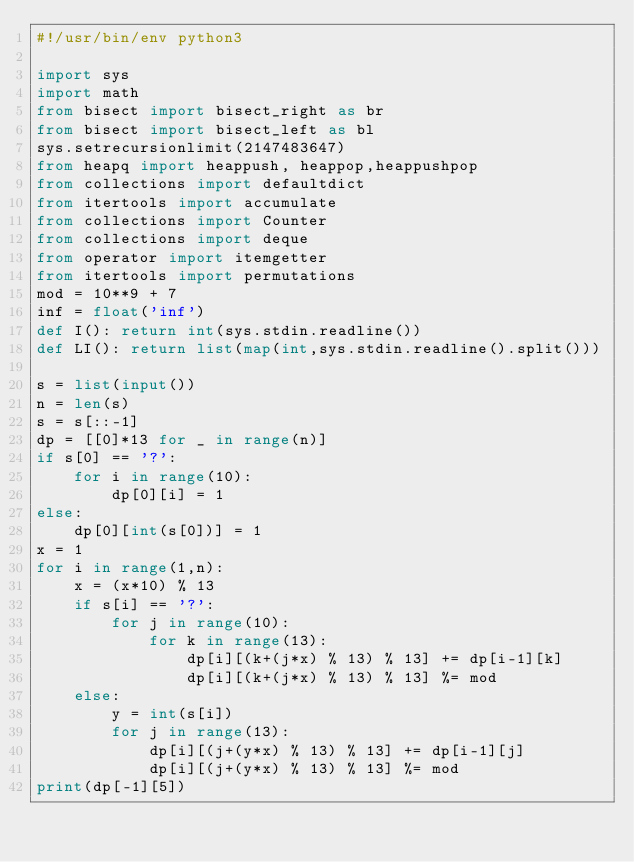Convert code to text. <code><loc_0><loc_0><loc_500><loc_500><_Python_>#!/usr/bin/env python3

import sys
import math
from bisect import bisect_right as br
from bisect import bisect_left as bl
sys.setrecursionlimit(2147483647)
from heapq import heappush, heappop,heappushpop
from collections import defaultdict
from itertools import accumulate
from collections import Counter
from collections import deque
from operator import itemgetter
from itertools import permutations
mod = 10**9 + 7
inf = float('inf')
def I(): return int(sys.stdin.readline())
def LI(): return list(map(int,sys.stdin.readline().split()))

s = list(input())
n = len(s)
s = s[::-1]
dp = [[0]*13 for _ in range(n)]
if s[0] == '?':
    for i in range(10):
        dp[0][i] = 1
else:
    dp[0][int(s[0])] = 1
x = 1
for i in range(1,n):
    x = (x*10) % 13
    if s[i] == '?':
        for j in range(10):
            for k in range(13):
                dp[i][(k+(j*x) % 13) % 13] += dp[i-1][k]
                dp[i][(k+(j*x) % 13) % 13] %= mod
    else:
        y = int(s[i])
        for j in range(13):
            dp[i][(j+(y*x) % 13) % 13] += dp[i-1][j]
            dp[i][(j+(y*x) % 13) % 13] %= mod
print(dp[-1][5])
</code> 